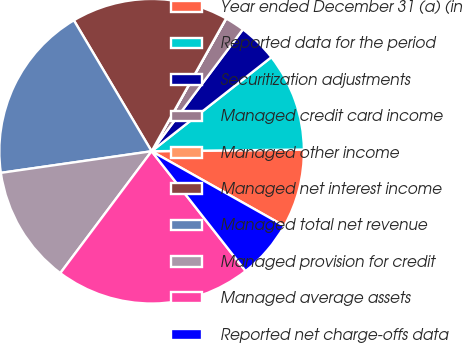<chart> <loc_0><loc_0><loc_500><loc_500><pie_chart><fcel>Year ended December 31 (a) (in<fcel>Reported data for the period<fcel>Securitization adjustments<fcel>Managed credit card income<fcel>Managed other income<fcel>Managed net interest income<fcel>Managed total net revenue<fcel>Managed provision for credit<fcel>Managed average assets<fcel>Reported net charge-offs data<nl><fcel>8.34%<fcel>10.42%<fcel>4.17%<fcel>2.09%<fcel>0.01%<fcel>16.66%<fcel>18.74%<fcel>12.5%<fcel>20.82%<fcel>6.25%<nl></chart> 